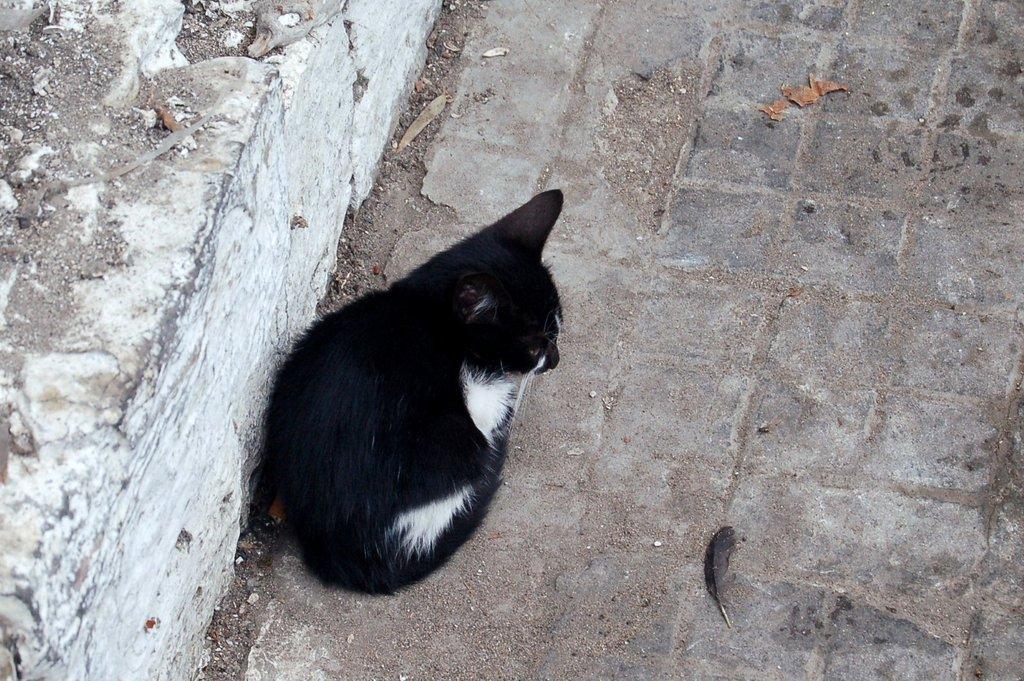In one or two sentences, can you explain what this image depicts? In the picture I can see a black color cat is sitting on the ground. On the left side of the image I can see a white color wall. 